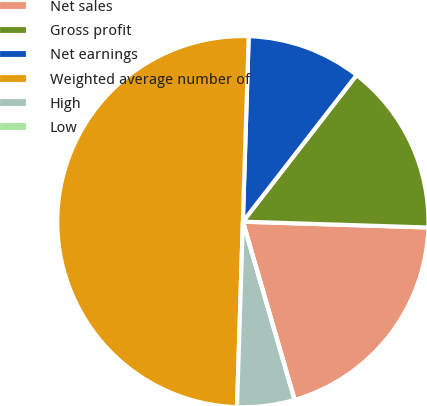<chart> <loc_0><loc_0><loc_500><loc_500><pie_chart><fcel>Net sales<fcel>Gross profit<fcel>Net earnings<fcel>Weighted average number of<fcel>High<fcel>Low<nl><fcel>20.0%<fcel>15.0%<fcel>10.0%<fcel>50.0%<fcel>5.0%<fcel>0.0%<nl></chart> 